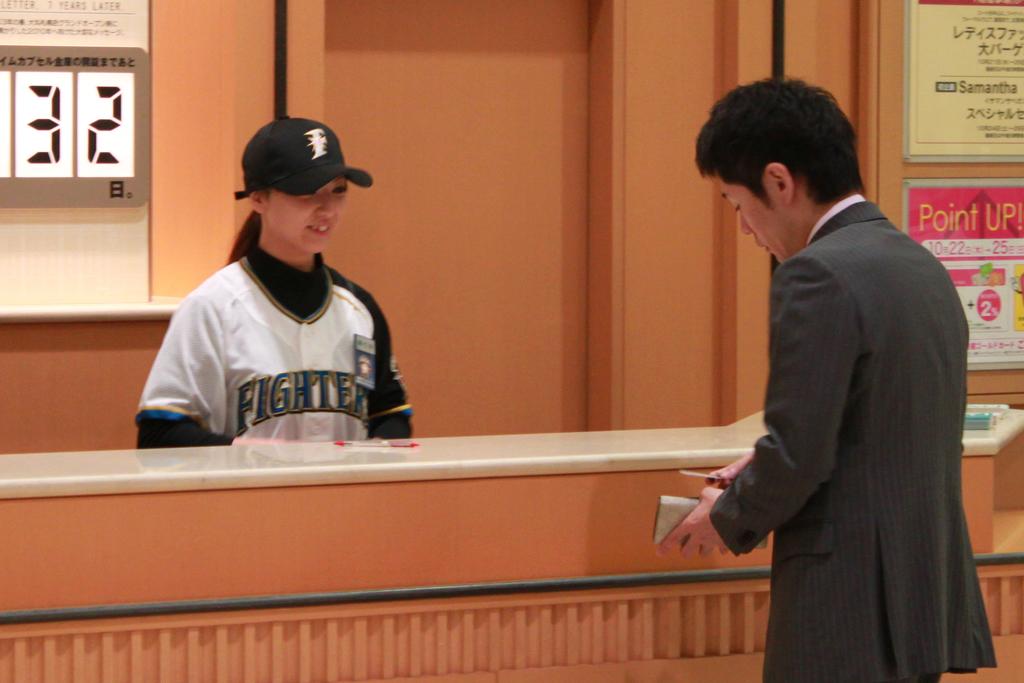What number is on the sign behind the girl?
Keep it short and to the point. 32. What team is she representing?
Keep it short and to the point. Fighters. 